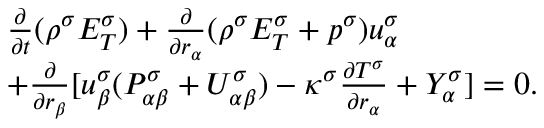Convert formula to latex. <formula><loc_0><loc_0><loc_500><loc_500>\begin{array} { r } { \begin{array} { r l } & { \frac { \partial } { \partial t } ( \rho ^ { \sigma } E _ { T } ^ { \sigma } ) + \frac { \partial } { \partial r _ { \alpha } } ( \rho ^ { \sigma } E _ { T } ^ { \sigma } + p ^ { \sigma } ) u _ { \alpha } ^ { \sigma } } \\ & { + \frac { \partial } { \partial r _ { \beta } } [ u _ { \beta } ^ { \sigma } ( P _ { \alpha \beta } ^ { \sigma } + U _ { \alpha \beta } ^ { \sigma } ) - \kappa ^ { \sigma } \frac { \partial T ^ { \sigma } } { \partial r _ { \alpha } } + Y _ { \alpha } ^ { \sigma } ] = 0 . } \end{array} } \end{array}</formula> 